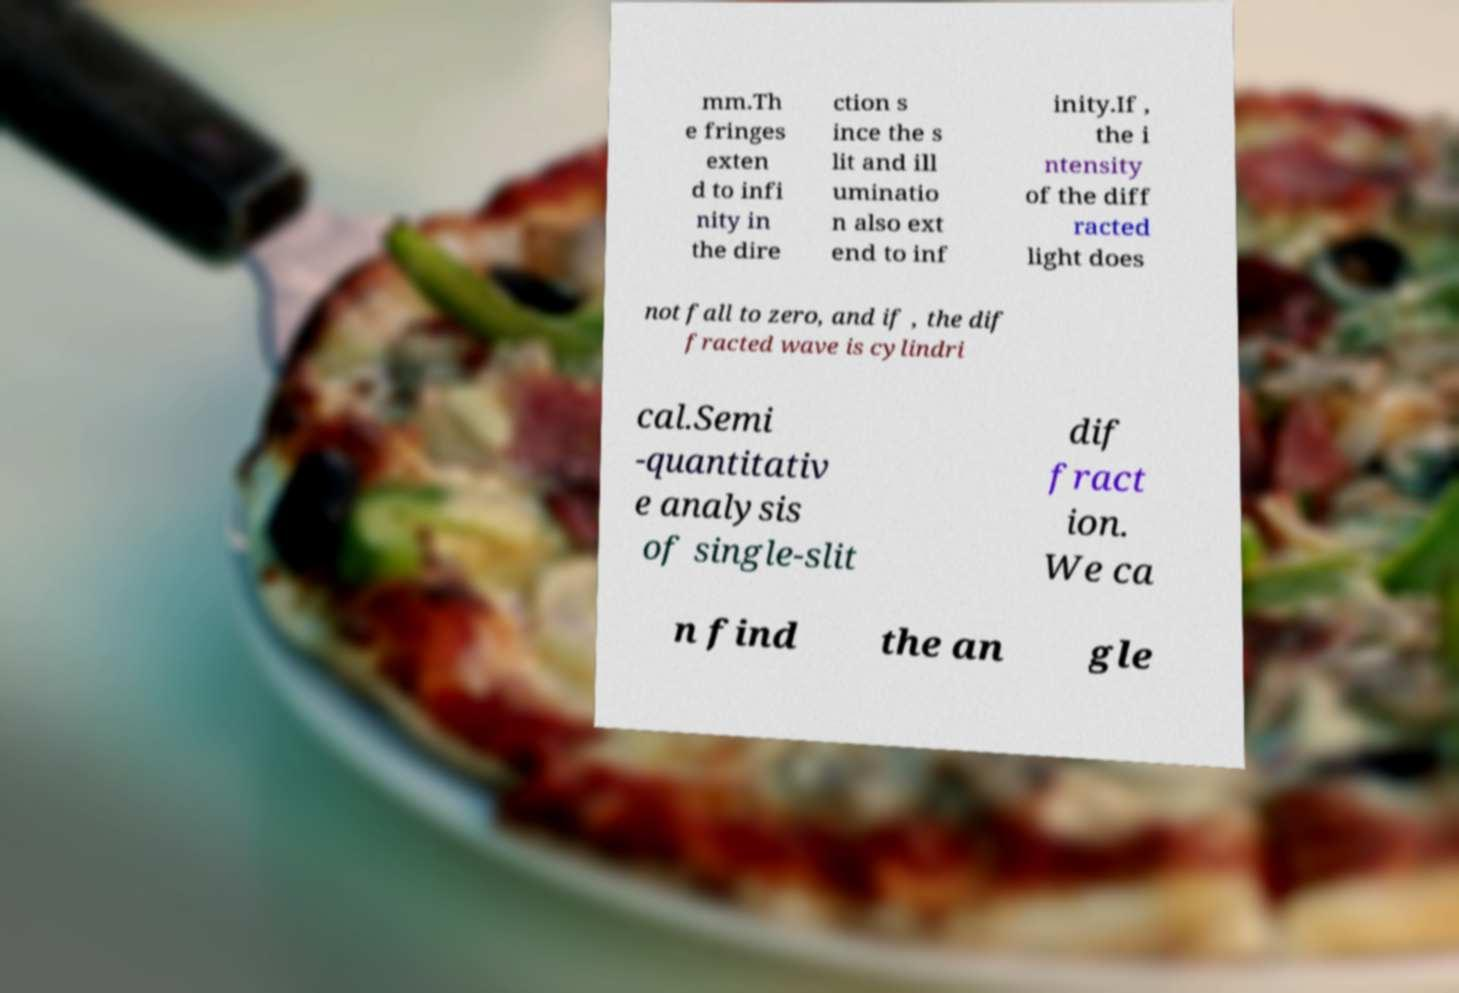I need the written content from this picture converted into text. Can you do that? mm.Th e fringes exten d to infi nity in the dire ction s ince the s lit and ill uminatio n also ext end to inf inity.If , the i ntensity of the diff racted light does not fall to zero, and if , the dif fracted wave is cylindri cal.Semi -quantitativ e analysis of single-slit dif fract ion. We ca n find the an gle 